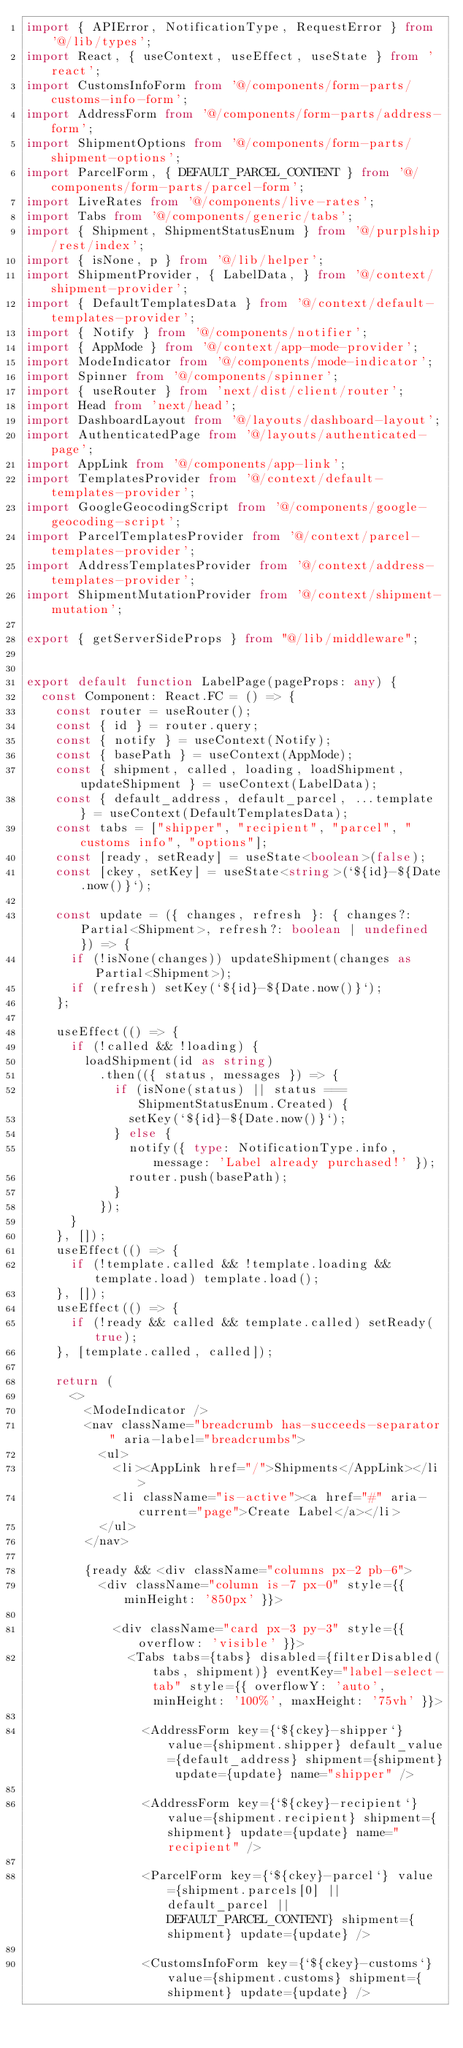Convert code to text. <code><loc_0><loc_0><loc_500><loc_500><_TypeScript_>import { APIError, NotificationType, RequestError } from '@/lib/types';
import React, { useContext, useEffect, useState } from 'react';
import CustomsInfoForm from '@/components/form-parts/customs-info-form';
import AddressForm from '@/components/form-parts/address-form';
import ShipmentOptions from '@/components/form-parts/shipment-options';
import ParcelForm, { DEFAULT_PARCEL_CONTENT } from '@/components/form-parts/parcel-form';
import LiveRates from '@/components/live-rates';
import Tabs from '@/components/generic/tabs';
import { Shipment, ShipmentStatusEnum } from '@/purplship/rest/index';
import { isNone, p } from '@/lib/helper';
import ShipmentProvider, { LabelData, } from '@/context/shipment-provider';
import { DefaultTemplatesData } from '@/context/default-templates-provider';
import { Notify } from '@/components/notifier';
import { AppMode } from '@/context/app-mode-provider';
import ModeIndicator from '@/components/mode-indicator';
import Spinner from '@/components/spinner';
import { useRouter } from 'next/dist/client/router';
import Head from 'next/head';
import DashboardLayout from '@/layouts/dashboard-layout';
import AuthenticatedPage from '@/layouts/authenticated-page';
import AppLink from '@/components/app-link';
import TemplatesProvider from '@/context/default-templates-provider';
import GoogleGeocodingScript from '@/components/google-geocoding-script';
import ParcelTemplatesProvider from '@/context/parcel-templates-provider';
import AddressTemplatesProvider from '@/context/address-templates-provider';
import ShipmentMutationProvider from '@/context/shipment-mutation';

export { getServerSideProps } from "@/lib/middleware";


export default function LabelPage(pageProps: any) {
  const Component: React.FC = () => {
    const router = useRouter();
    const { id } = router.query;
    const { notify } = useContext(Notify);
    const { basePath } = useContext(AppMode);
    const { shipment, called, loading, loadShipment, updateShipment } = useContext(LabelData);
    const { default_address, default_parcel, ...template } = useContext(DefaultTemplatesData);
    const tabs = ["shipper", "recipient", "parcel", "customs info", "options"];
    const [ready, setReady] = useState<boolean>(false);
    const [ckey, setKey] = useState<string>(`${id}-${Date.now()}`);

    const update = ({ changes, refresh }: { changes?: Partial<Shipment>, refresh?: boolean | undefined }) => {
      if (!isNone(changes)) updateShipment(changes as Partial<Shipment>);
      if (refresh) setKey(`${id}-${Date.now()}`);
    };

    useEffect(() => {
      if (!called && !loading) {
        loadShipment(id as string)
          .then(({ status, messages }) => {
            if (isNone(status) || status === ShipmentStatusEnum.Created) {
              setKey(`${id}-${Date.now()}`);
            } else {
              notify({ type: NotificationType.info, message: 'Label already purchased!' });
              router.push(basePath);
            }
          });
      }
    }, []);
    useEffect(() => {
      if (!template.called && !template.loading && template.load) template.load();
    }, []);
    useEffect(() => {
      if (!ready && called && template.called) setReady(true);
    }, [template.called, called]);

    return (
      <>
        <ModeIndicator />
        <nav className="breadcrumb has-succeeds-separator" aria-label="breadcrumbs">
          <ul>
            <li><AppLink href="/">Shipments</AppLink></li>
            <li className="is-active"><a href="#" aria-current="page">Create Label</a></li>
          </ul>
        </nav>

        {ready && <div className="columns px-2 pb-6">
          <div className="column is-7 px-0" style={{ minHeight: '850px' }}>

            <div className="card px-3 py-3" style={{ overflow: 'visible' }}>
              <Tabs tabs={tabs} disabled={filterDisabled(tabs, shipment)} eventKey="label-select-tab" style={{ overflowY: 'auto', minHeight: '100%', maxHeight: '75vh' }}>

                <AddressForm key={`${ckey}-shipper`} value={shipment.shipper} default_value={default_address} shipment={shipment} update={update} name="shipper" />

                <AddressForm key={`${ckey}-recipient`} value={shipment.recipient} shipment={shipment} update={update} name="recipient" />

                <ParcelForm key={`${ckey}-parcel`} value={shipment.parcels[0] || default_parcel || DEFAULT_PARCEL_CONTENT} shipment={shipment} update={update} />

                <CustomsInfoForm key={`${ckey}-customs`} value={shipment.customs} shipment={shipment} update={update} />
</code> 